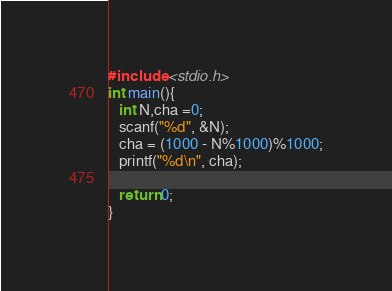Convert code to text. <code><loc_0><loc_0><loc_500><loc_500><_C_>#include <stdio.h>
int main(){
   int N,cha =0;
   scanf("%d", &N);
   cha = (1000 - N%1000)%1000;
   printf("%d\n", cha);
   
   return 0;
}</code> 